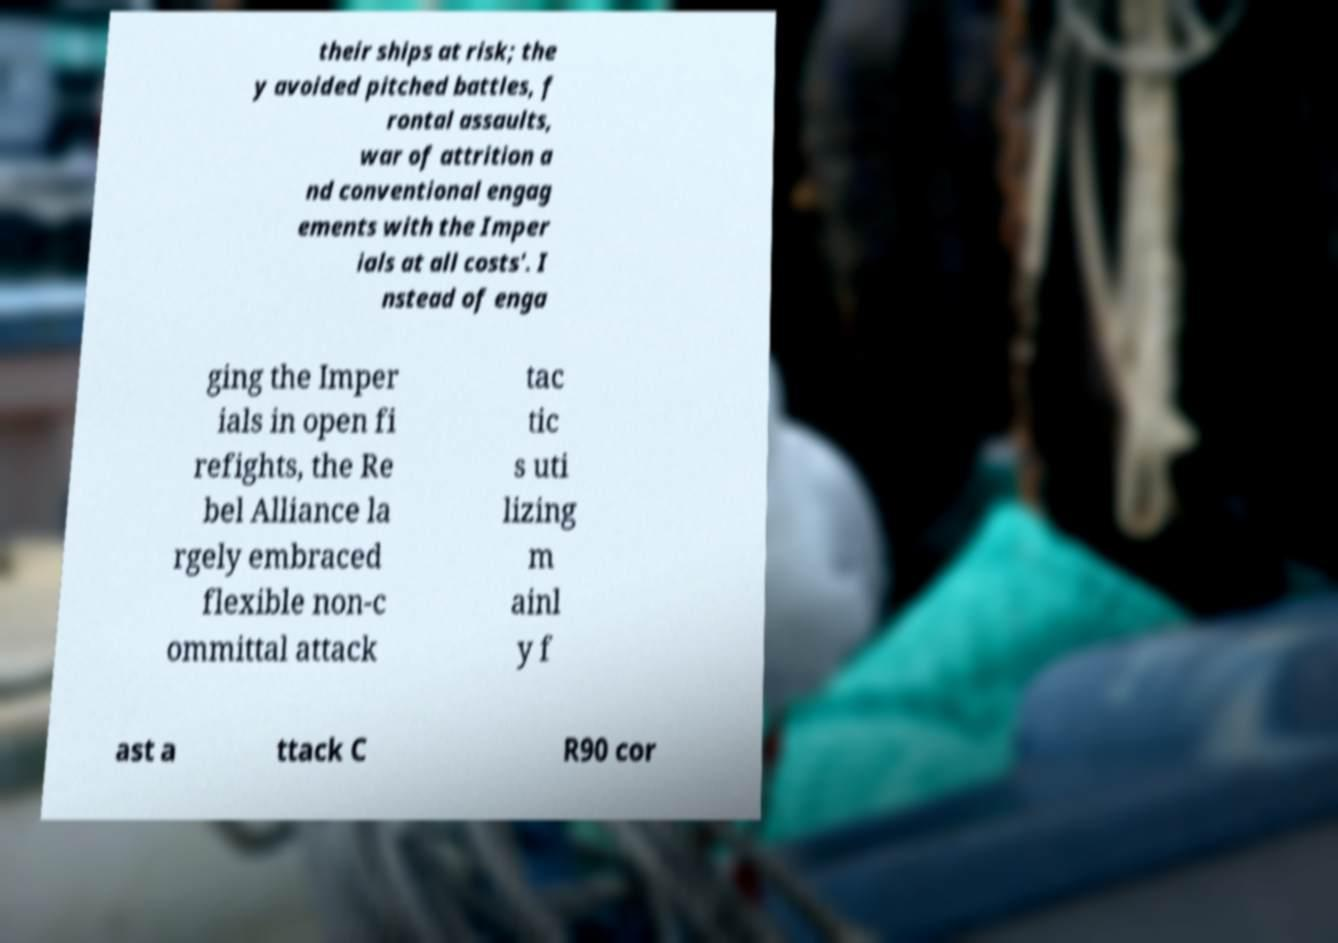Could you extract and type out the text from this image? their ships at risk; the y avoided pitched battles, f rontal assaults, war of attrition a nd conventional engag ements with the Imper ials at all costs'. I nstead of enga ging the Imper ials in open fi refights, the Re bel Alliance la rgely embraced flexible non-c ommittal attack tac tic s uti lizing m ainl y f ast a ttack C R90 cor 